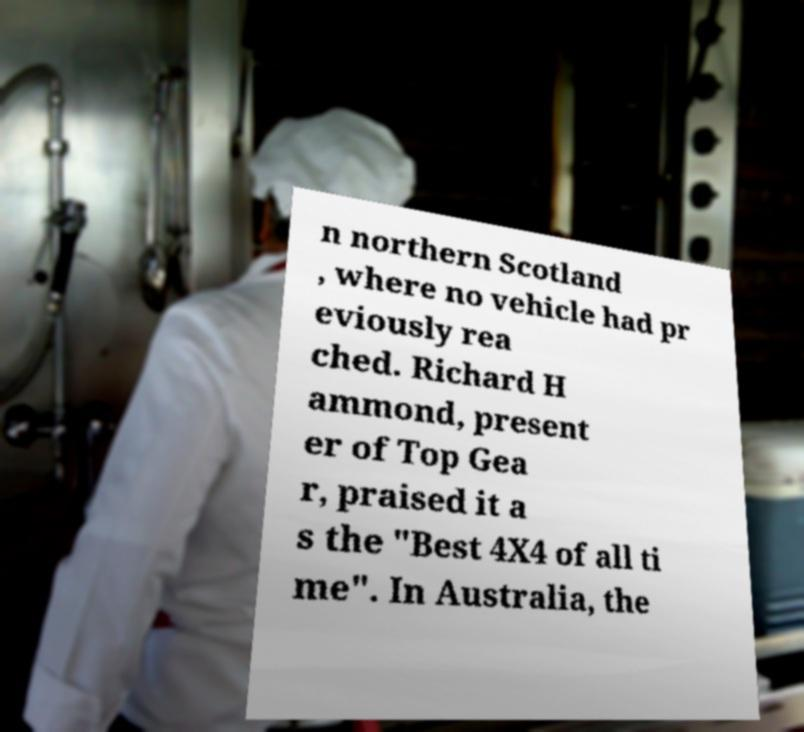Please identify and transcribe the text found in this image. n northern Scotland , where no vehicle had pr eviously rea ched. Richard H ammond, present er of Top Gea r, praised it a s the "Best 4X4 of all ti me". In Australia, the 